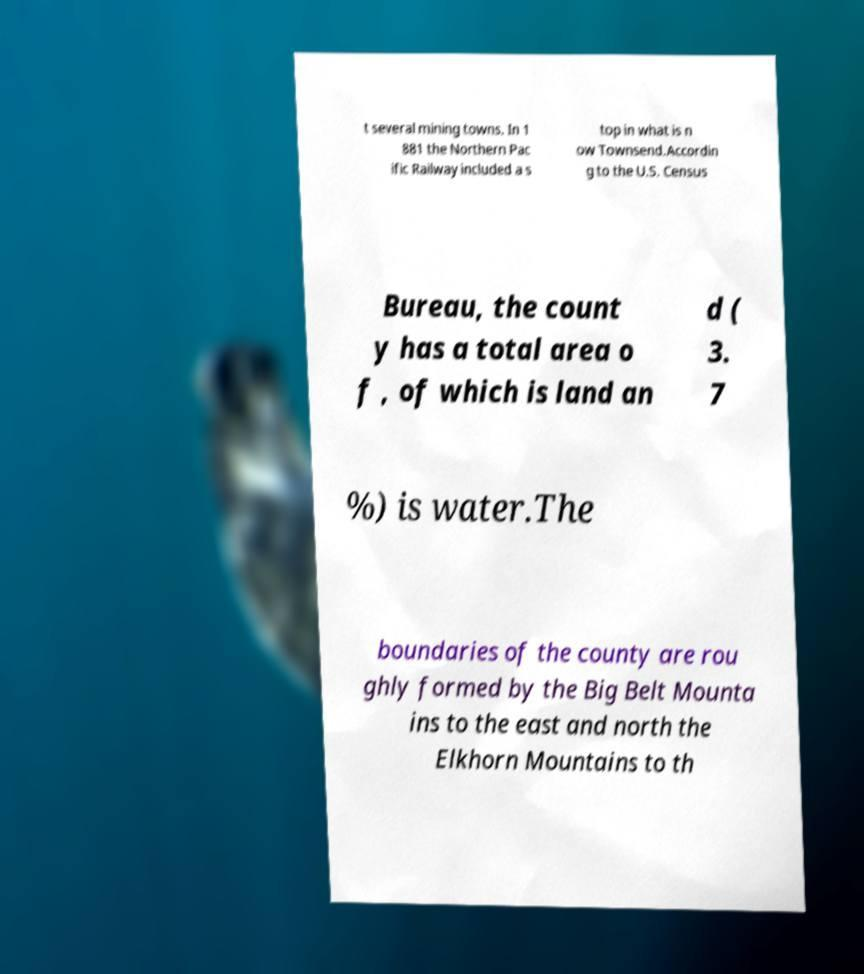For documentation purposes, I need the text within this image transcribed. Could you provide that? t several mining towns. In 1 881 the Northern Pac ific Railway included a s top in what is n ow Townsend.Accordin g to the U.S. Census Bureau, the count y has a total area o f , of which is land an d ( 3. 7 %) is water.The boundaries of the county are rou ghly formed by the Big Belt Mounta ins to the east and north the Elkhorn Mountains to th 